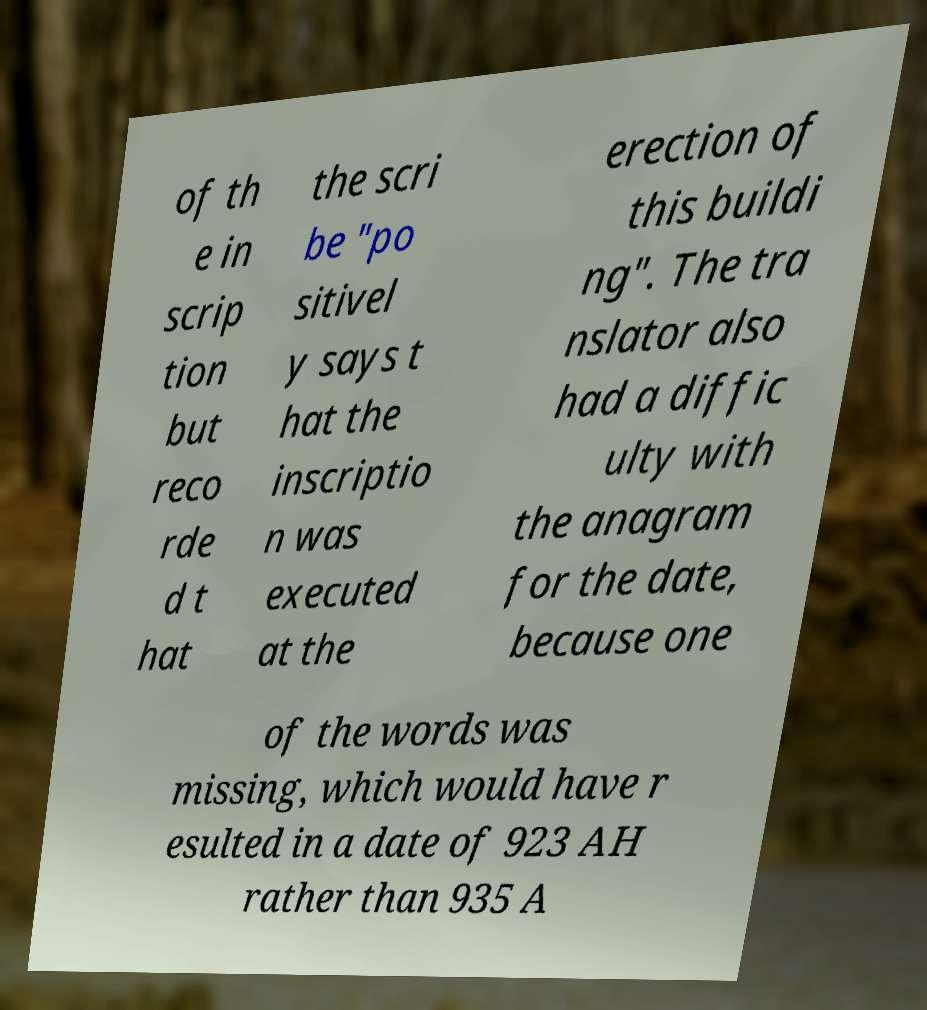What messages or text are displayed in this image? I need them in a readable, typed format. of th e in scrip tion but reco rde d t hat the scri be "po sitivel y says t hat the inscriptio n was executed at the erection of this buildi ng". The tra nslator also had a diffic ulty with the anagram for the date, because one of the words was missing, which would have r esulted in a date of 923 AH rather than 935 A 